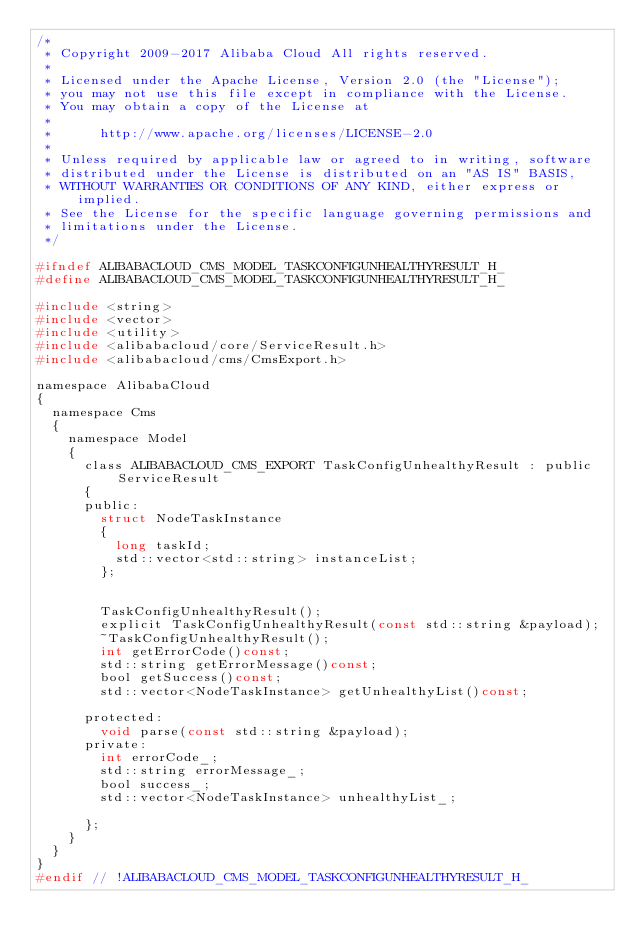<code> <loc_0><loc_0><loc_500><loc_500><_C_>/*
 * Copyright 2009-2017 Alibaba Cloud All rights reserved.
 * 
 * Licensed under the Apache License, Version 2.0 (the "License");
 * you may not use this file except in compliance with the License.
 * You may obtain a copy of the License at
 * 
 *      http://www.apache.org/licenses/LICENSE-2.0
 * 
 * Unless required by applicable law or agreed to in writing, software
 * distributed under the License is distributed on an "AS IS" BASIS,
 * WITHOUT WARRANTIES OR CONDITIONS OF ANY KIND, either express or implied.
 * See the License for the specific language governing permissions and
 * limitations under the License.
 */

#ifndef ALIBABACLOUD_CMS_MODEL_TASKCONFIGUNHEALTHYRESULT_H_
#define ALIBABACLOUD_CMS_MODEL_TASKCONFIGUNHEALTHYRESULT_H_

#include <string>
#include <vector>
#include <utility>
#include <alibabacloud/core/ServiceResult.h>
#include <alibabacloud/cms/CmsExport.h>

namespace AlibabaCloud
{
	namespace Cms
	{
		namespace Model
		{
			class ALIBABACLOUD_CMS_EXPORT TaskConfigUnhealthyResult : public ServiceResult
			{
			public:
				struct NodeTaskInstance
				{
					long taskId;
					std::vector<std::string> instanceList;
				};


				TaskConfigUnhealthyResult();
				explicit TaskConfigUnhealthyResult(const std::string &payload);
				~TaskConfigUnhealthyResult();
				int getErrorCode()const;
				std::string getErrorMessage()const;
				bool getSuccess()const;
				std::vector<NodeTaskInstance> getUnhealthyList()const;

			protected:
				void parse(const std::string &payload);
			private:
				int errorCode_;
				std::string errorMessage_;
				bool success_;
				std::vector<NodeTaskInstance> unhealthyList_;

			};
		}
	}
}
#endif // !ALIBABACLOUD_CMS_MODEL_TASKCONFIGUNHEALTHYRESULT_H_</code> 